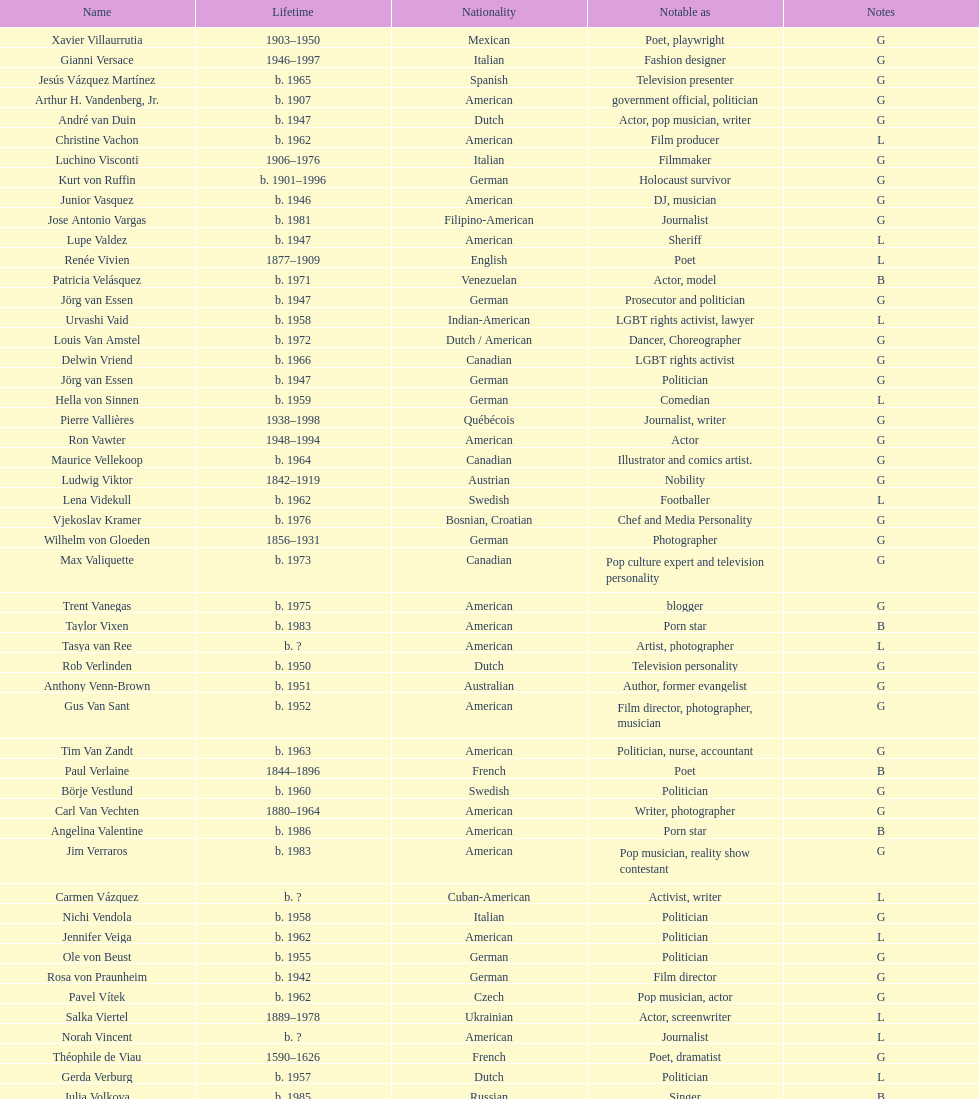Which nationality has the most people associated with it? American. 